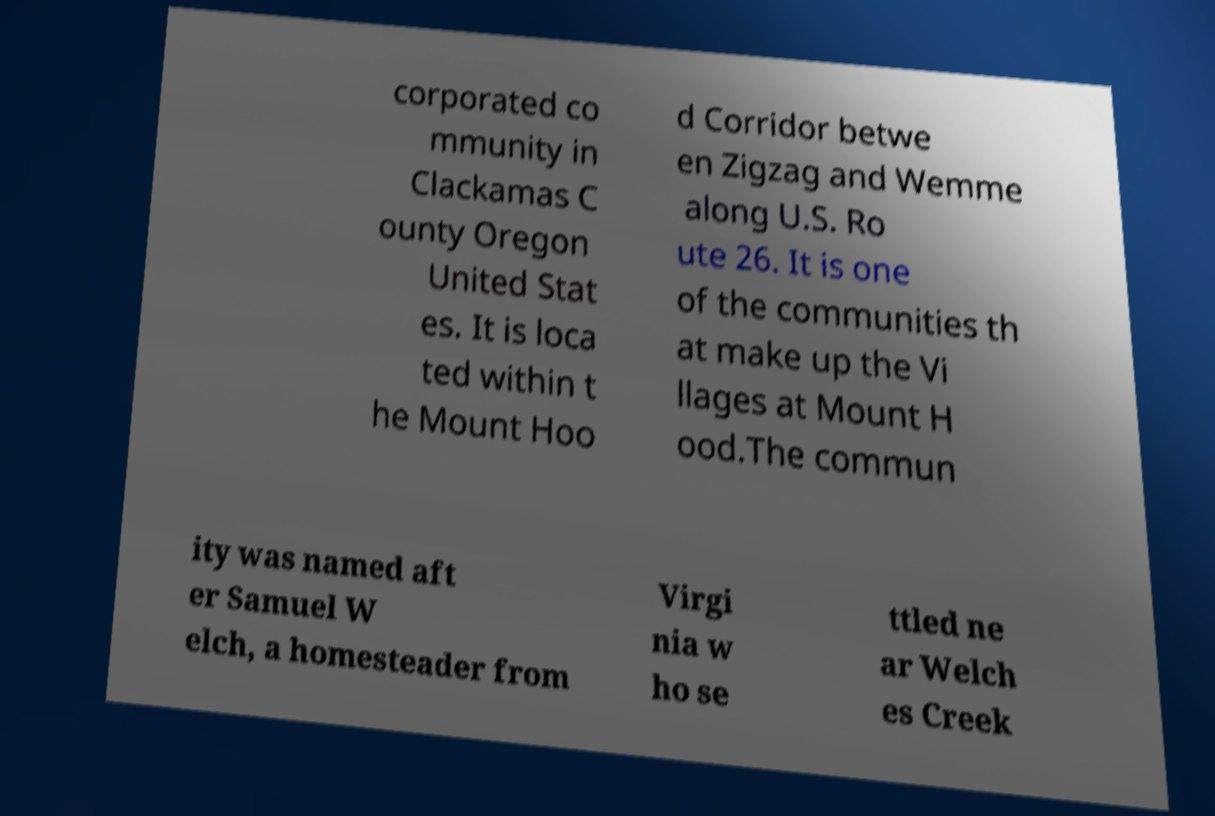Can you accurately transcribe the text from the provided image for me? corporated co mmunity in Clackamas C ounty Oregon United Stat es. It is loca ted within t he Mount Hoo d Corridor betwe en Zigzag and Wemme along U.S. Ro ute 26. It is one of the communities th at make up the Vi llages at Mount H ood.The commun ity was named aft er Samuel W elch, a homesteader from Virgi nia w ho se ttled ne ar Welch es Creek 